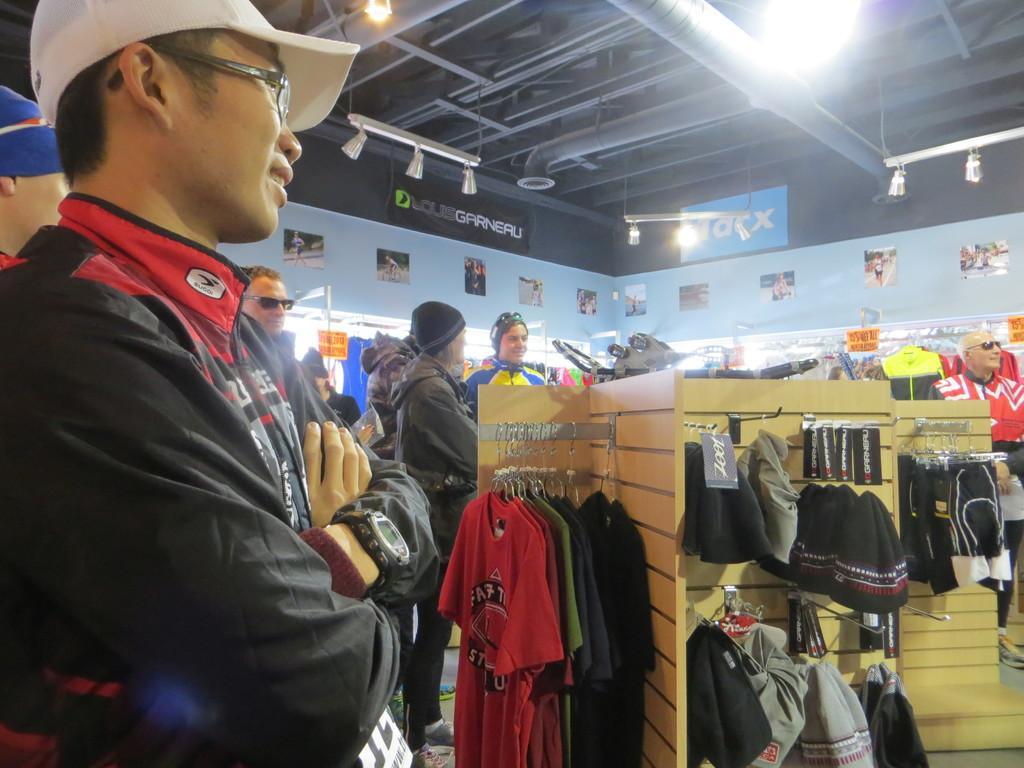How would you summarize this image in a sentence or two? This view is inside a shopping store, there are a few people doing shopping, in the background of the image we can see clothes and other accessories. 